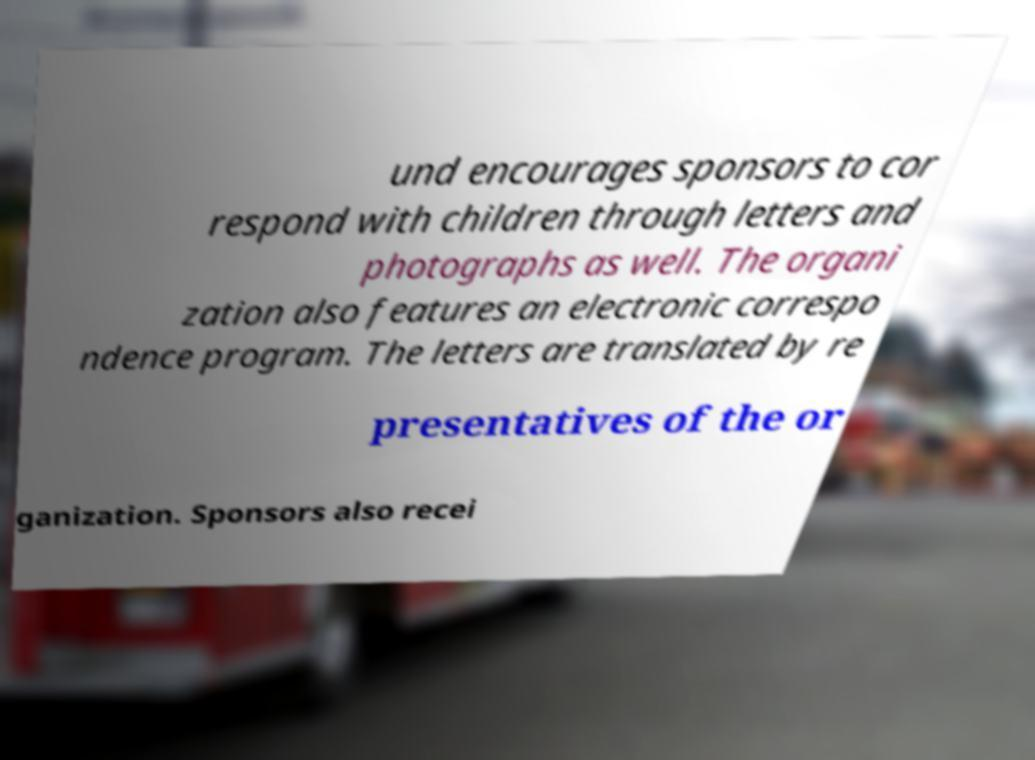I need the written content from this picture converted into text. Can you do that? und encourages sponsors to cor respond with children through letters and photographs as well. The organi zation also features an electronic correspo ndence program. The letters are translated by re presentatives of the or ganization. Sponsors also recei 